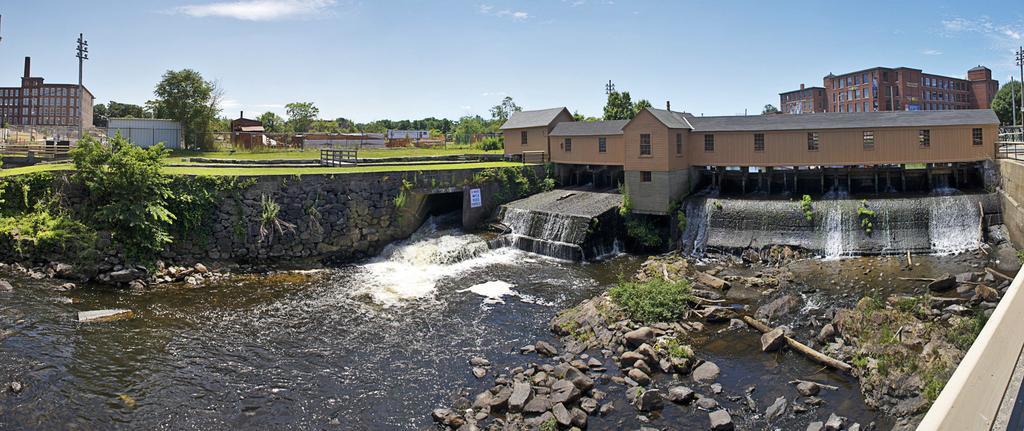How would you summarize this image in a sentence or two? In this picture there is water and pebbles at the bottom side of the image and there are houses and trees at the top side of the image and there are pole at the top side of the image. 